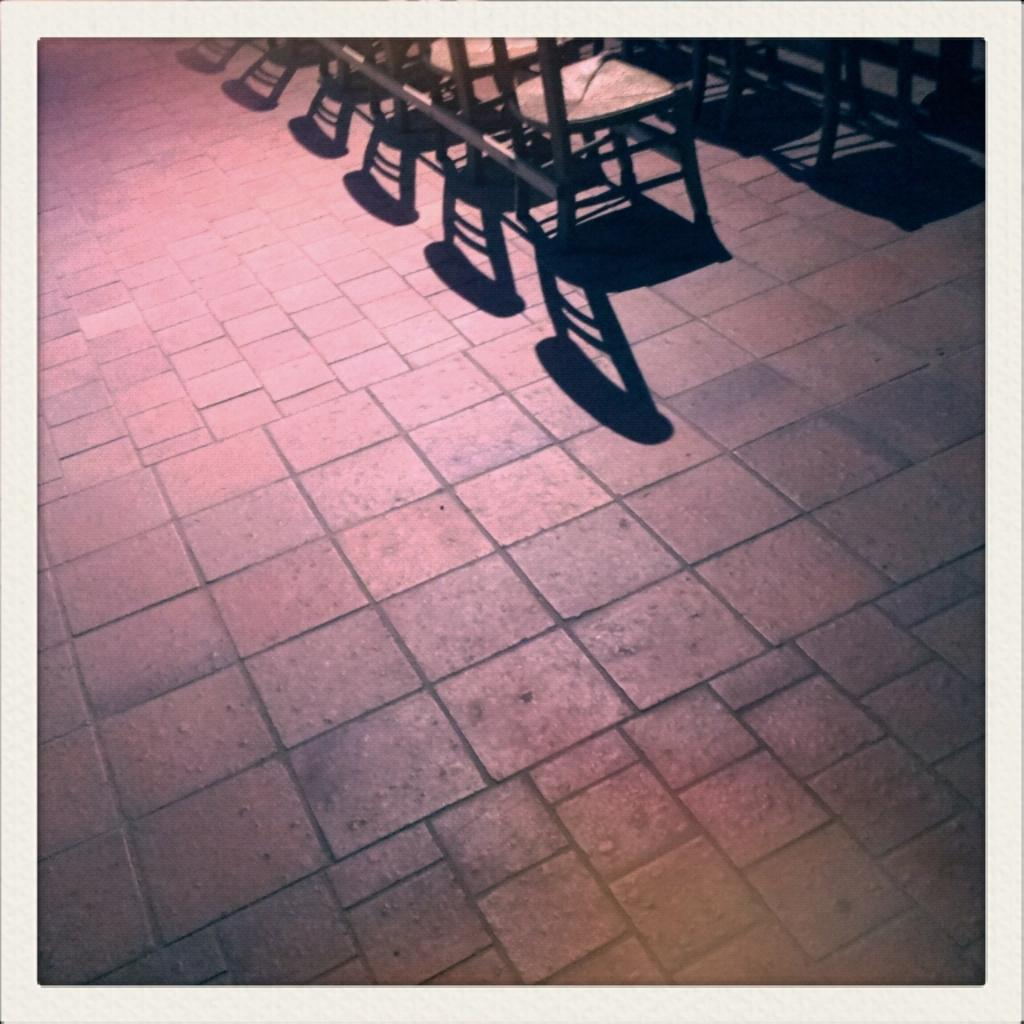What type of chairs are in the image? There are wooden chairs in the image. Where are the wooden chairs located? The wooden chairs are on the floor. Can you describe any additional features of the chairs in the image? The shadow of the chairs is visible in the image. Are there any rabbits visible in the image? There are no rabbits present in the image. What type of cough medicine is recommended for the chairs in the image? The chairs in the image do not require cough medicine, as they are inanimate objects. 